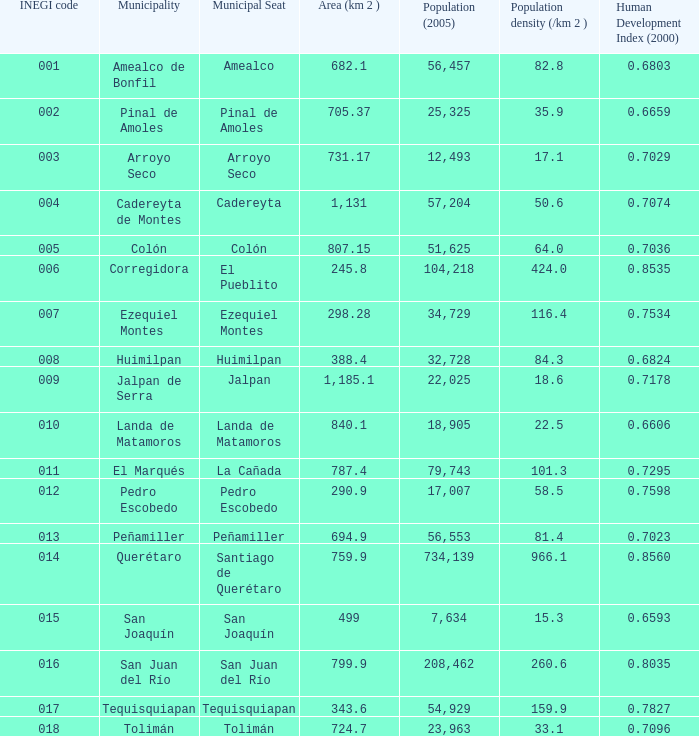WHich INEGI code has a Population density (/km 2 ) smaller than 81.4 and 0.6593 Human Development Index (2000)? 15.0. 